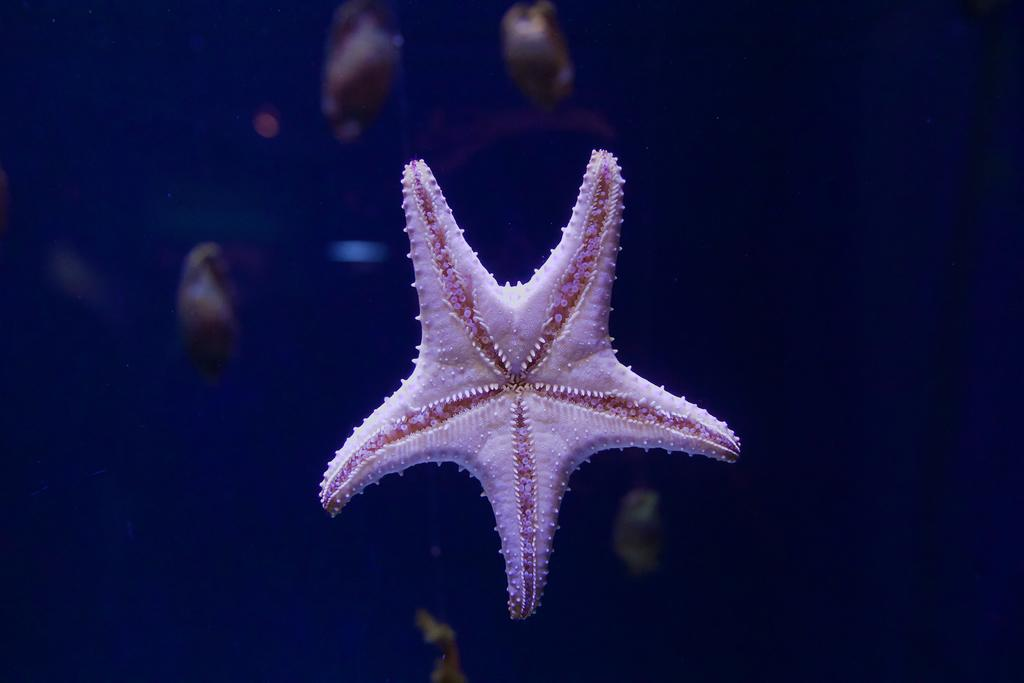What is the main subject of the image? There is a starfish in the image. Can you describe the background of the image? The background of the image is blurred. How many friends are present in the image? There is no mention of friends in the image, as it only features a starfish. What type of crime is being committed in the image? There is no crime present in the image; it only features a starfish. 